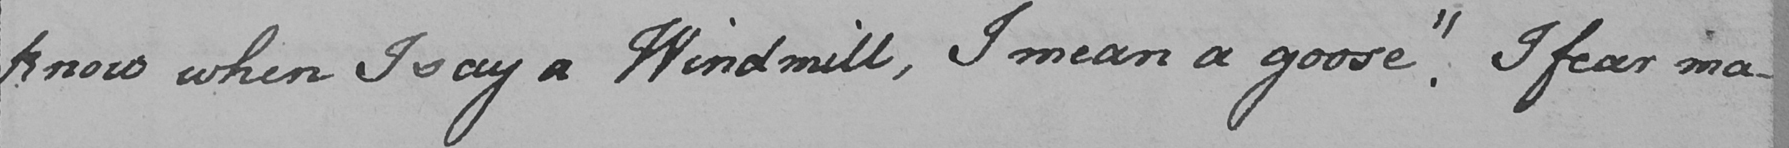Please transcribe the handwritten text in this image. know when I say a Windmill , I mean a goose . "  I fear ma- 